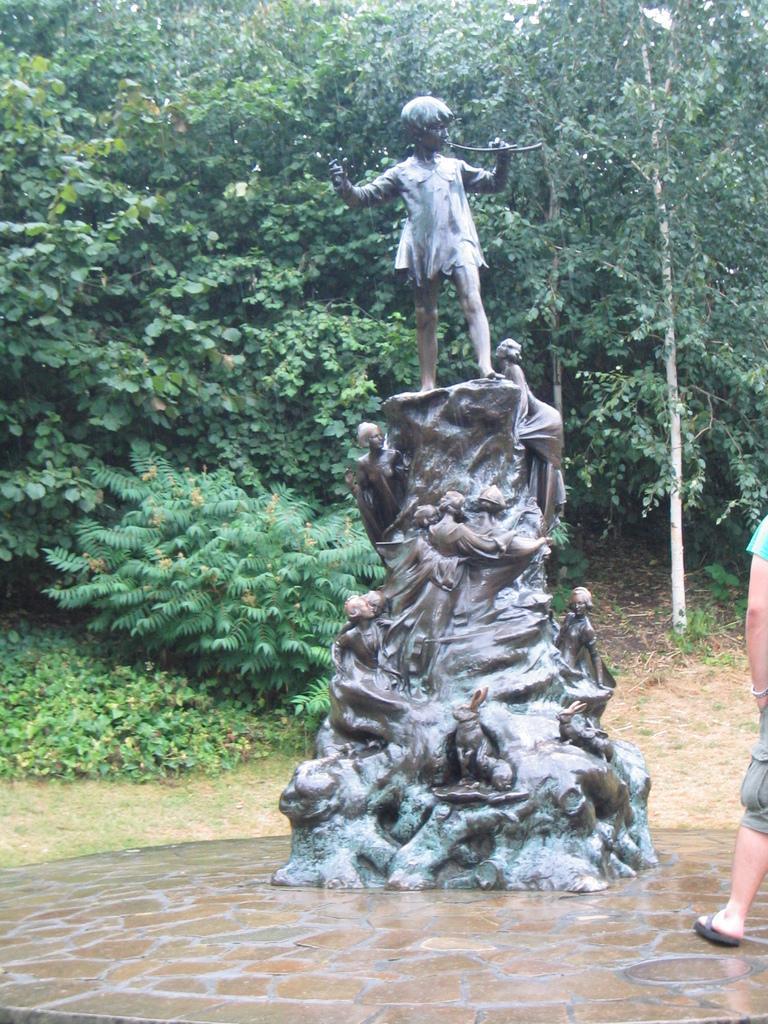Could you give a brief overview of what you see in this image? In the center of the image there is a statue. On the right side of the image there is a person standing. In the background of the image there are trees. 